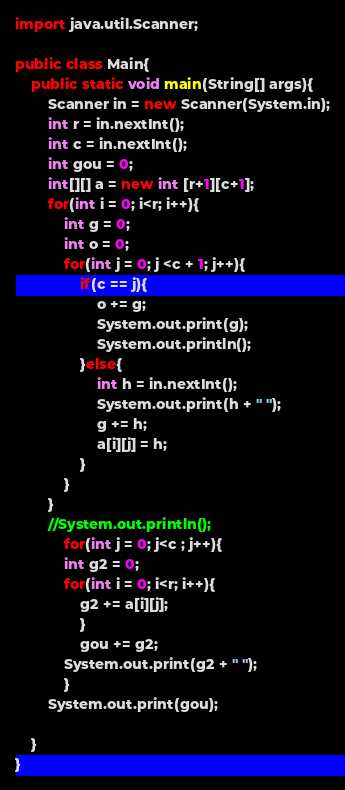<code> <loc_0><loc_0><loc_500><loc_500><_Java_>import java.util.Scanner;
 
public class Main{
    public static void main(String[] args){
        Scanner in = new Scanner(System.in);
        int r = in.nextInt();
        int c = in.nextInt();
        int gou = 0;
        int[][] a = new int [r+1][c+1];
        for(int i = 0; i<r; i++){
            int g = 0;
            int o = 0;
            for(int j = 0; j <c + 1; j++){
                if(c == j){
                    o += g;
                    System.out.print(g);
                    System.out.println(); 
                }else{
                    int h = in.nextInt();
                    System.out.print(h + " ");
                    g += h;
                    a[i][j] = h;
                }
            }
        }
        //System.out.println();
            for(int j = 0; j<c ; j++){
            int g2 = 0;
            for(int i = 0; i<r; i++){
                g2 += a[i][j];
                }
                gou += g2;
            System.out.print(g2 + " ");
            }
        System.out.print(gou);
 
    }
}</code> 